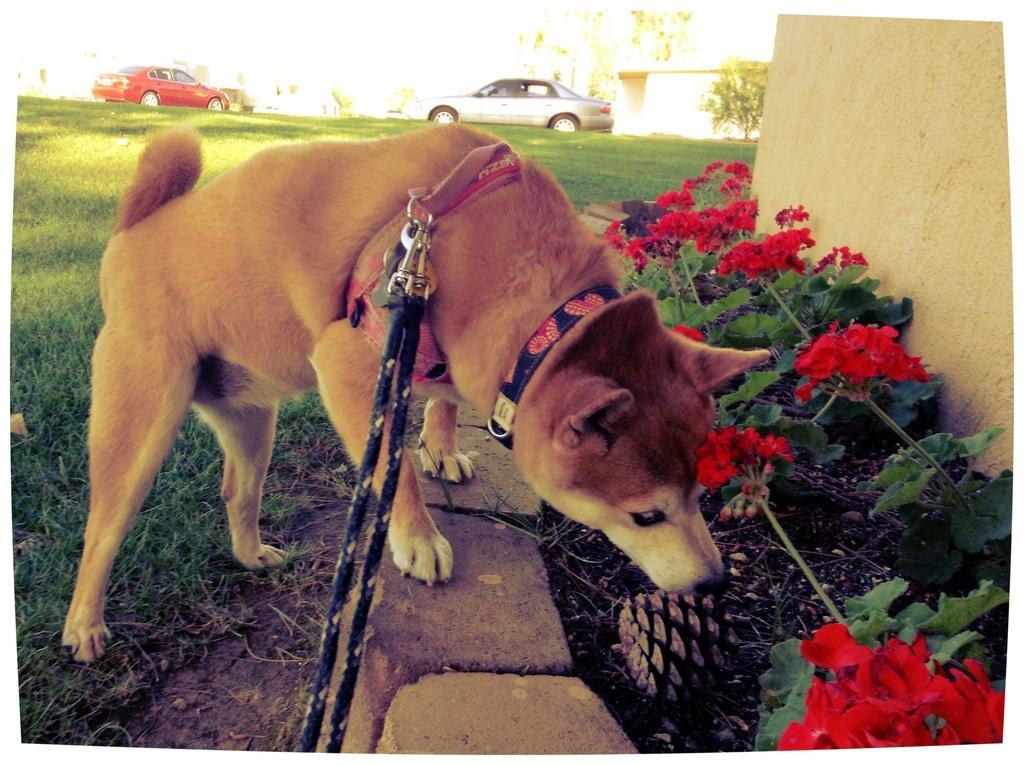Can you describe this image briefly? There is a dog with belt and we can see grass, flowers, plants and wall. Background we can see cars and tree. 